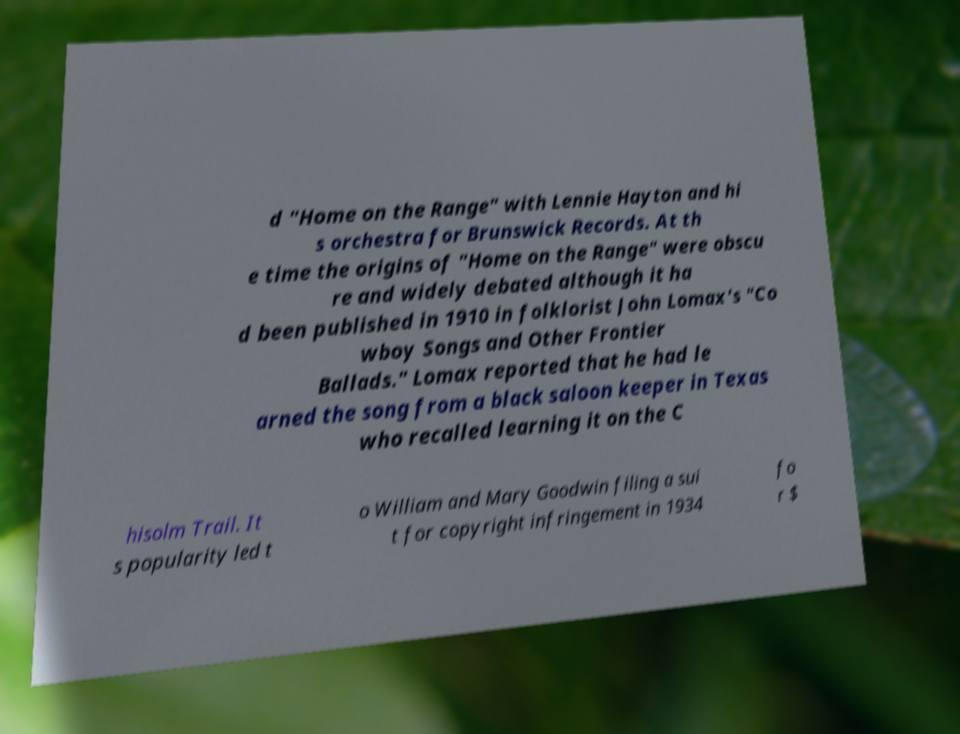I need the written content from this picture converted into text. Can you do that? d "Home on the Range" with Lennie Hayton and hi s orchestra for Brunswick Records. At th e time the origins of "Home on the Range" were obscu re and widely debated although it ha d been published in 1910 in folklorist John Lomax's "Co wboy Songs and Other Frontier Ballads." Lomax reported that he had le arned the song from a black saloon keeper in Texas who recalled learning it on the C hisolm Trail. It s popularity led t o William and Mary Goodwin filing a sui t for copyright infringement in 1934 fo r $ 